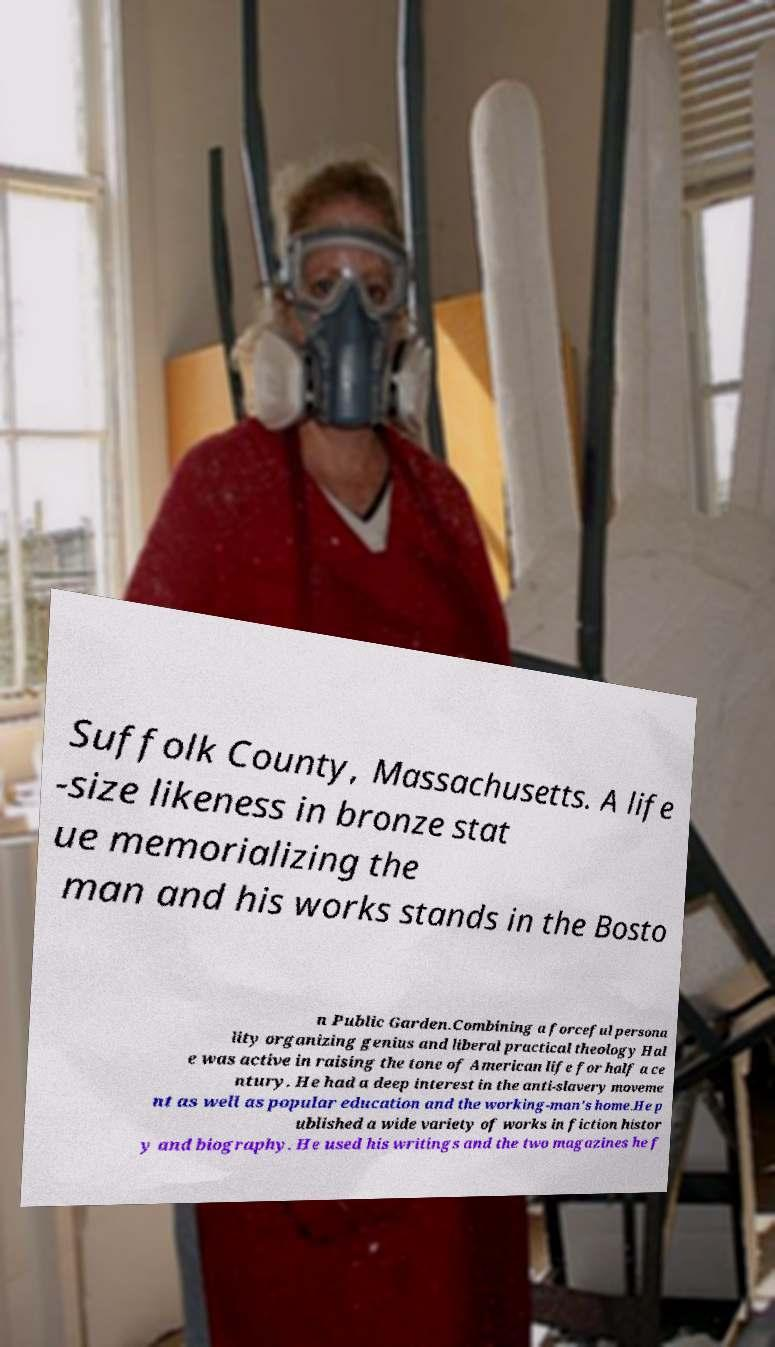For documentation purposes, I need the text within this image transcribed. Could you provide that? Suffolk County, Massachusetts. A life -size likeness in bronze stat ue memorializing the man and his works stands in the Bosto n Public Garden.Combining a forceful persona lity organizing genius and liberal practical theology Hal e was active in raising the tone of American life for half a ce ntury. He had a deep interest in the anti-slavery moveme nt as well as popular education and the working-man's home.He p ublished a wide variety of works in fiction histor y and biography. He used his writings and the two magazines he f 